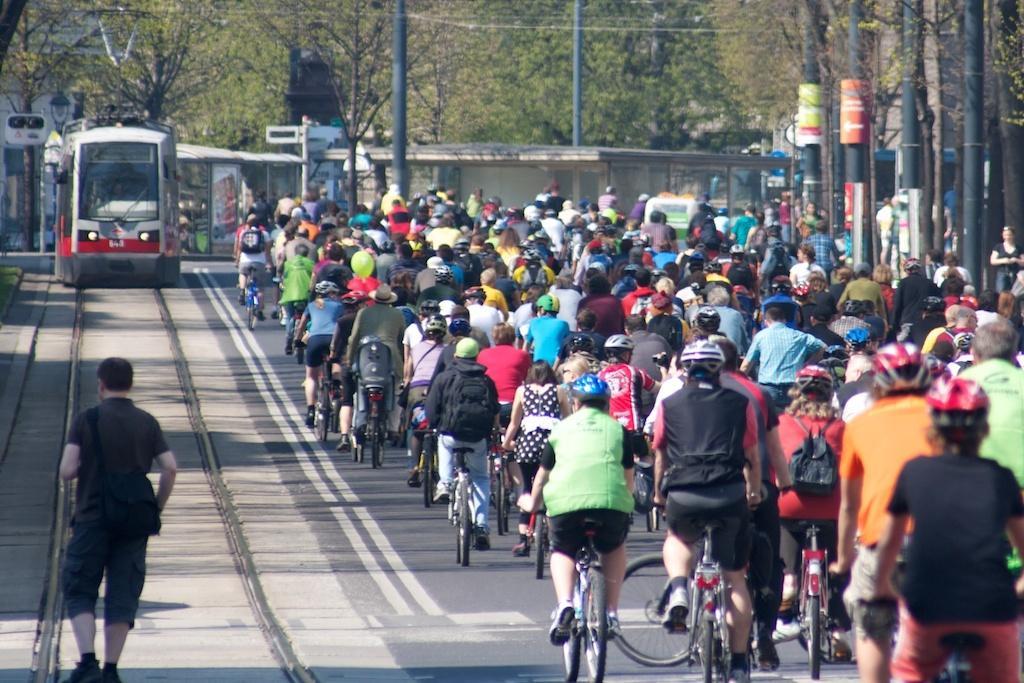Please provide a concise description of this image. In this im age left corner there are few group of people riding bicycles. Left side a person in walking. Left side there is a train and there is a lamp. Background of the image is having trees. Right side corner there are few poles. 